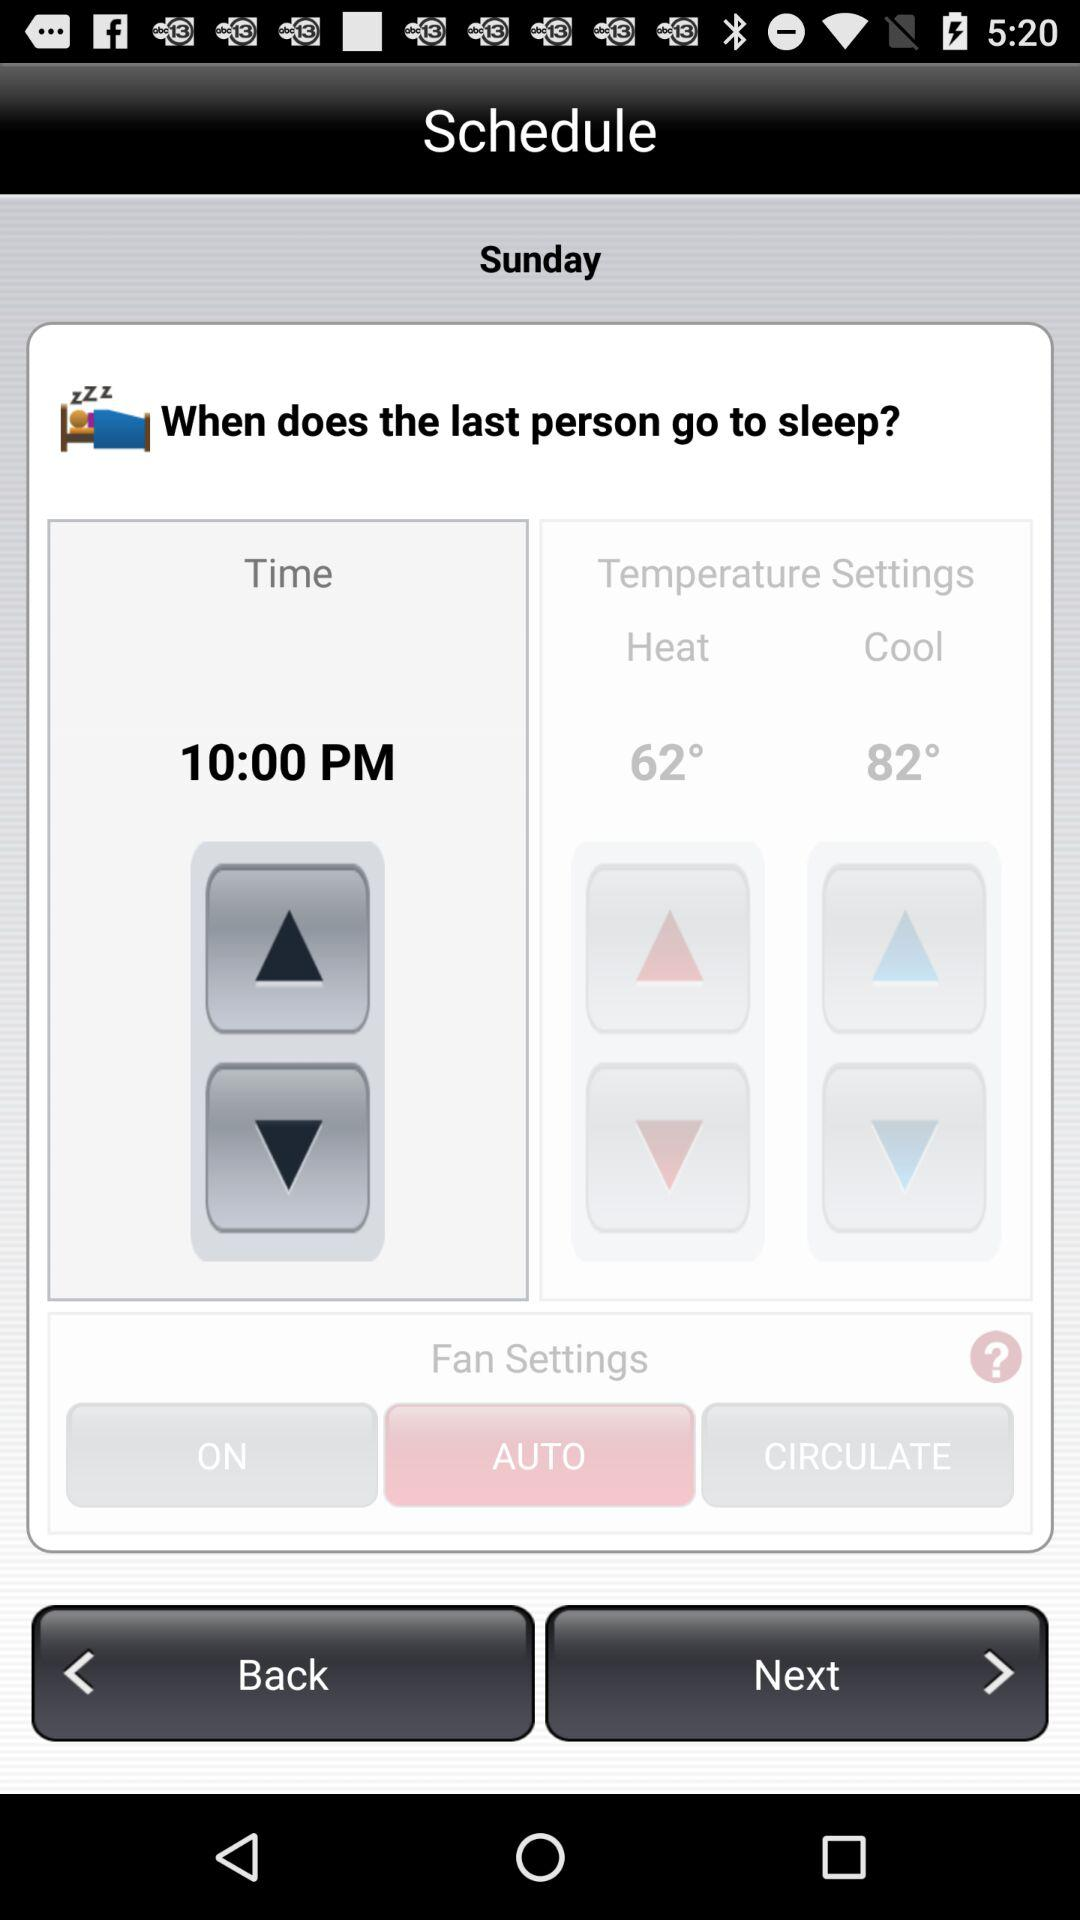What is the time? The time is 10:00 PM. 